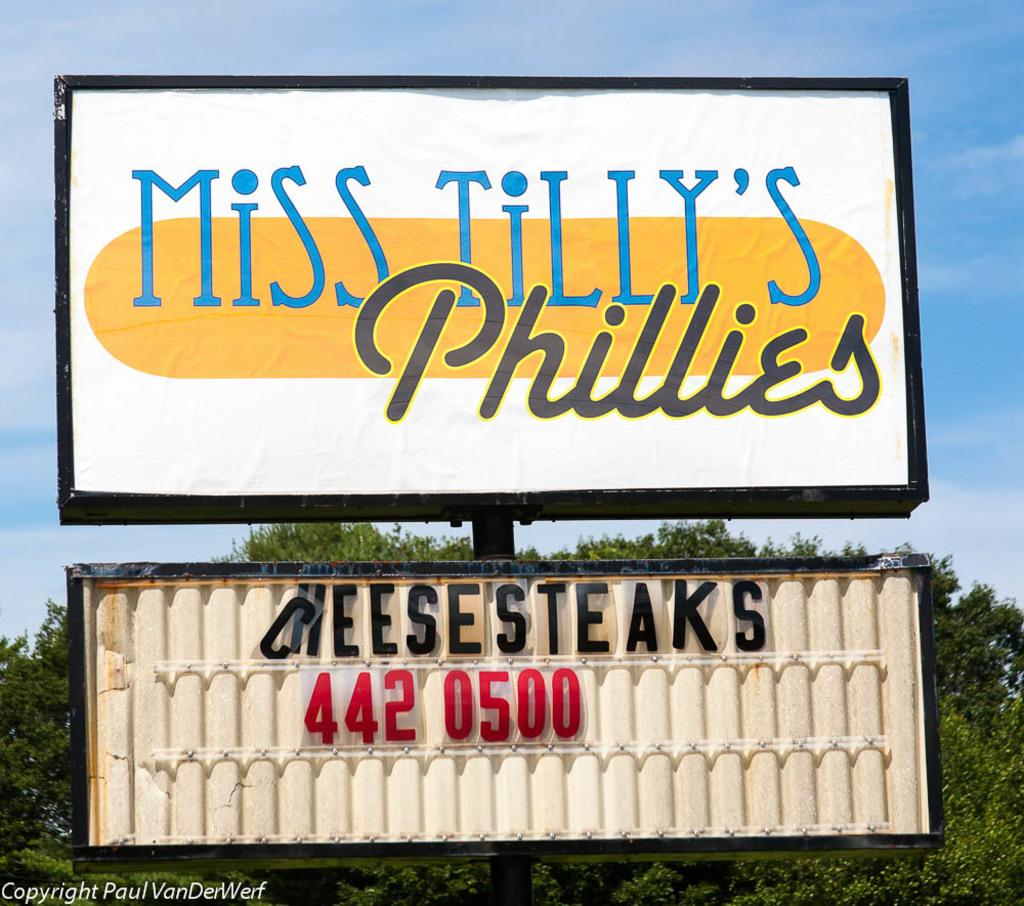What is the main structure in the image? There are two boards on a pole in the image. What is written or depicted on the boards? There is text with colors on the boards. What can be seen in the background of the image? There is a tree and the sky visible in the background of the image. How many sticks are being burned in the image? There are no sticks being burned in the image; it features two boards on a pole with text and colors. 